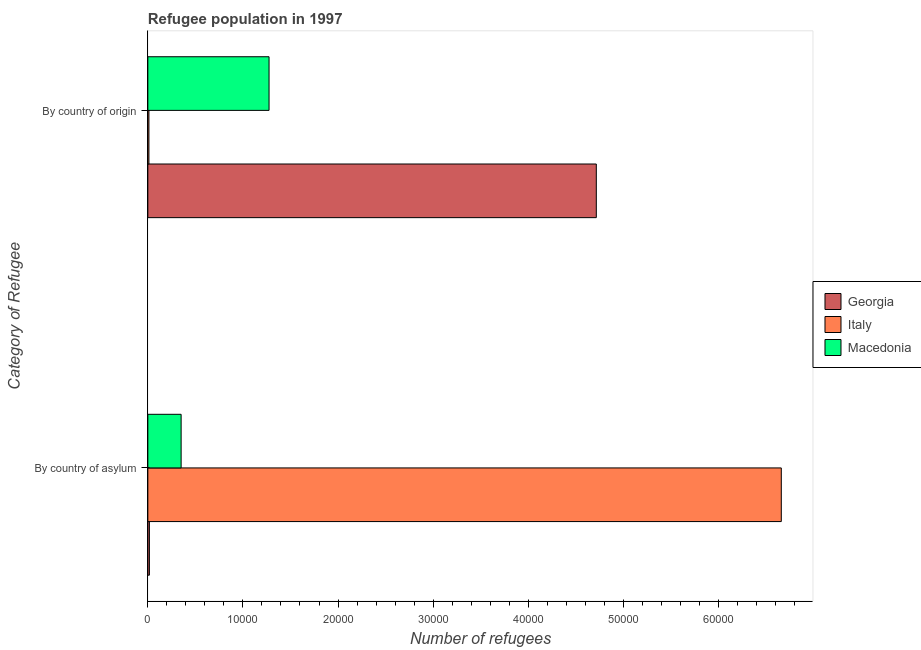How many different coloured bars are there?
Give a very brief answer. 3. What is the label of the 2nd group of bars from the top?
Offer a very short reply. By country of asylum. What is the number of refugees by country of asylum in Italy?
Provide a succinct answer. 6.66e+04. Across all countries, what is the maximum number of refugees by country of origin?
Make the answer very short. 4.72e+04. Across all countries, what is the minimum number of refugees by country of asylum?
Make the answer very short. 162. In which country was the number of refugees by country of asylum minimum?
Give a very brief answer. Georgia. What is the total number of refugees by country of asylum in the graph?
Make the answer very short. 7.03e+04. What is the difference between the number of refugees by country of origin in Georgia and that in Italy?
Keep it short and to the point. 4.71e+04. What is the difference between the number of refugees by country of asylum in Georgia and the number of refugees by country of origin in Italy?
Offer a very short reply. 50. What is the average number of refugees by country of asylum per country?
Your answer should be very brief. 2.34e+04. What is the difference between the number of refugees by country of asylum and number of refugees by country of origin in Macedonia?
Make the answer very short. -9247. In how many countries, is the number of refugees by country of origin greater than 24000 ?
Make the answer very short. 1. What is the ratio of the number of refugees by country of asylum in Macedonia to that in Italy?
Provide a short and direct response. 0.05. Is the number of refugees by country of asylum in Macedonia less than that in Georgia?
Your response must be concise. No. In how many countries, is the number of refugees by country of origin greater than the average number of refugees by country of origin taken over all countries?
Ensure brevity in your answer.  1. What does the 1st bar from the top in By country of origin represents?
Provide a succinct answer. Macedonia. What does the 2nd bar from the bottom in By country of asylum represents?
Provide a succinct answer. Italy. How many bars are there?
Give a very brief answer. 6. What is the difference between two consecutive major ticks on the X-axis?
Your answer should be compact. 10000. Are the values on the major ticks of X-axis written in scientific E-notation?
Ensure brevity in your answer.  No. Does the graph contain grids?
Give a very brief answer. No. How are the legend labels stacked?
Provide a short and direct response. Vertical. What is the title of the graph?
Your answer should be very brief. Refugee population in 1997. What is the label or title of the X-axis?
Your answer should be compact. Number of refugees. What is the label or title of the Y-axis?
Offer a terse response. Category of Refugee. What is the Number of refugees in Georgia in By country of asylum?
Give a very brief answer. 162. What is the Number of refugees in Italy in By country of asylum?
Your answer should be very brief. 6.66e+04. What is the Number of refugees of Macedonia in By country of asylum?
Make the answer very short. 3500. What is the Number of refugees in Georgia in By country of origin?
Keep it short and to the point. 4.72e+04. What is the Number of refugees of Italy in By country of origin?
Keep it short and to the point. 112. What is the Number of refugees of Macedonia in By country of origin?
Your answer should be very brief. 1.27e+04. Across all Category of Refugee, what is the maximum Number of refugees of Georgia?
Offer a terse response. 4.72e+04. Across all Category of Refugee, what is the maximum Number of refugees in Italy?
Make the answer very short. 6.66e+04. Across all Category of Refugee, what is the maximum Number of refugees of Macedonia?
Keep it short and to the point. 1.27e+04. Across all Category of Refugee, what is the minimum Number of refugees in Georgia?
Ensure brevity in your answer.  162. Across all Category of Refugee, what is the minimum Number of refugees of Italy?
Give a very brief answer. 112. Across all Category of Refugee, what is the minimum Number of refugees in Macedonia?
Provide a short and direct response. 3500. What is the total Number of refugees of Georgia in the graph?
Offer a terse response. 4.73e+04. What is the total Number of refugees in Italy in the graph?
Offer a very short reply. 6.67e+04. What is the total Number of refugees of Macedonia in the graph?
Make the answer very short. 1.62e+04. What is the difference between the Number of refugees of Georgia in By country of asylum and that in By country of origin?
Make the answer very short. -4.70e+04. What is the difference between the Number of refugees of Italy in By country of asylum and that in By country of origin?
Ensure brevity in your answer.  6.65e+04. What is the difference between the Number of refugees in Macedonia in By country of asylum and that in By country of origin?
Your answer should be very brief. -9247. What is the difference between the Number of refugees in Georgia in By country of asylum and the Number of refugees in Macedonia in By country of origin?
Keep it short and to the point. -1.26e+04. What is the difference between the Number of refugees of Italy in By country of asylum and the Number of refugees of Macedonia in By country of origin?
Provide a short and direct response. 5.39e+04. What is the average Number of refugees in Georgia per Category of Refugee?
Offer a terse response. 2.37e+04. What is the average Number of refugees in Italy per Category of Refugee?
Your response must be concise. 3.34e+04. What is the average Number of refugees of Macedonia per Category of Refugee?
Your answer should be very brief. 8123.5. What is the difference between the Number of refugees of Georgia and Number of refugees of Italy in By country of asylum?
Your answer should be compact. -6.65e+04. What is the difference between the Number of refugees of Georgia and Number of refugees of Macedonia in By country of asylum?
Your response must be concise. -3338. What is the difference between the Number of refugees of Italy and Number of refugees of Macedonia in By country of asylum?
Give a very brief answer. 6.31e+04. What is the difference between the Number of refugees of Georgia and Number of refugees of Italy in By country of origin?
Your answer should be compact. 4.71e+04. What is the difference between the Number of refugees in Georgia and Number of refugees in Macedonia in By country of origin?
Make the answer very short. 3.44e+04. What is the difference between the Number of refugees in Italy and Number of refugees in Macedonia in By country of origin?
Offer a terse response. -1.26e+04. What is the ratio of the Number of refugees of Georgia in By country of asylum to that in By country of origin?
Provide a short and direct response. 0. What is the ratio of the Number of refugees of Italy in By country of asylum to that in By country of origin?
Ensure brevity in your answer.  594.82. What is the ratio of the Number of refugees in Macedonia in By country of asylum to that in By country of origin?
Offer a very short reply. 0.27. What is the difference between the highest and the second highest Number of refugees in Georgia?
Your response must be concise. 4.70e+04. What is the difference between the highest and the second highest Number of refugees of Italy?
Ensure brevity in your answer.  6.65e+04. What is the difference between the highest and the second highest Number of refugees of Macedonia?
Give a very brief answer. 9247. What is the difference between the highest and the lowest Number of refugees in Georgia?
Keep it short and to the point. 4.70e+04. What is the difference between the highest and the lowest Number of refugees in Italy?
Your answer should be very brief. 6.65e+04. What is the difference between the highest and the lowest Number of refugees of Macedonia?
Offer a very short reply. 9247. 